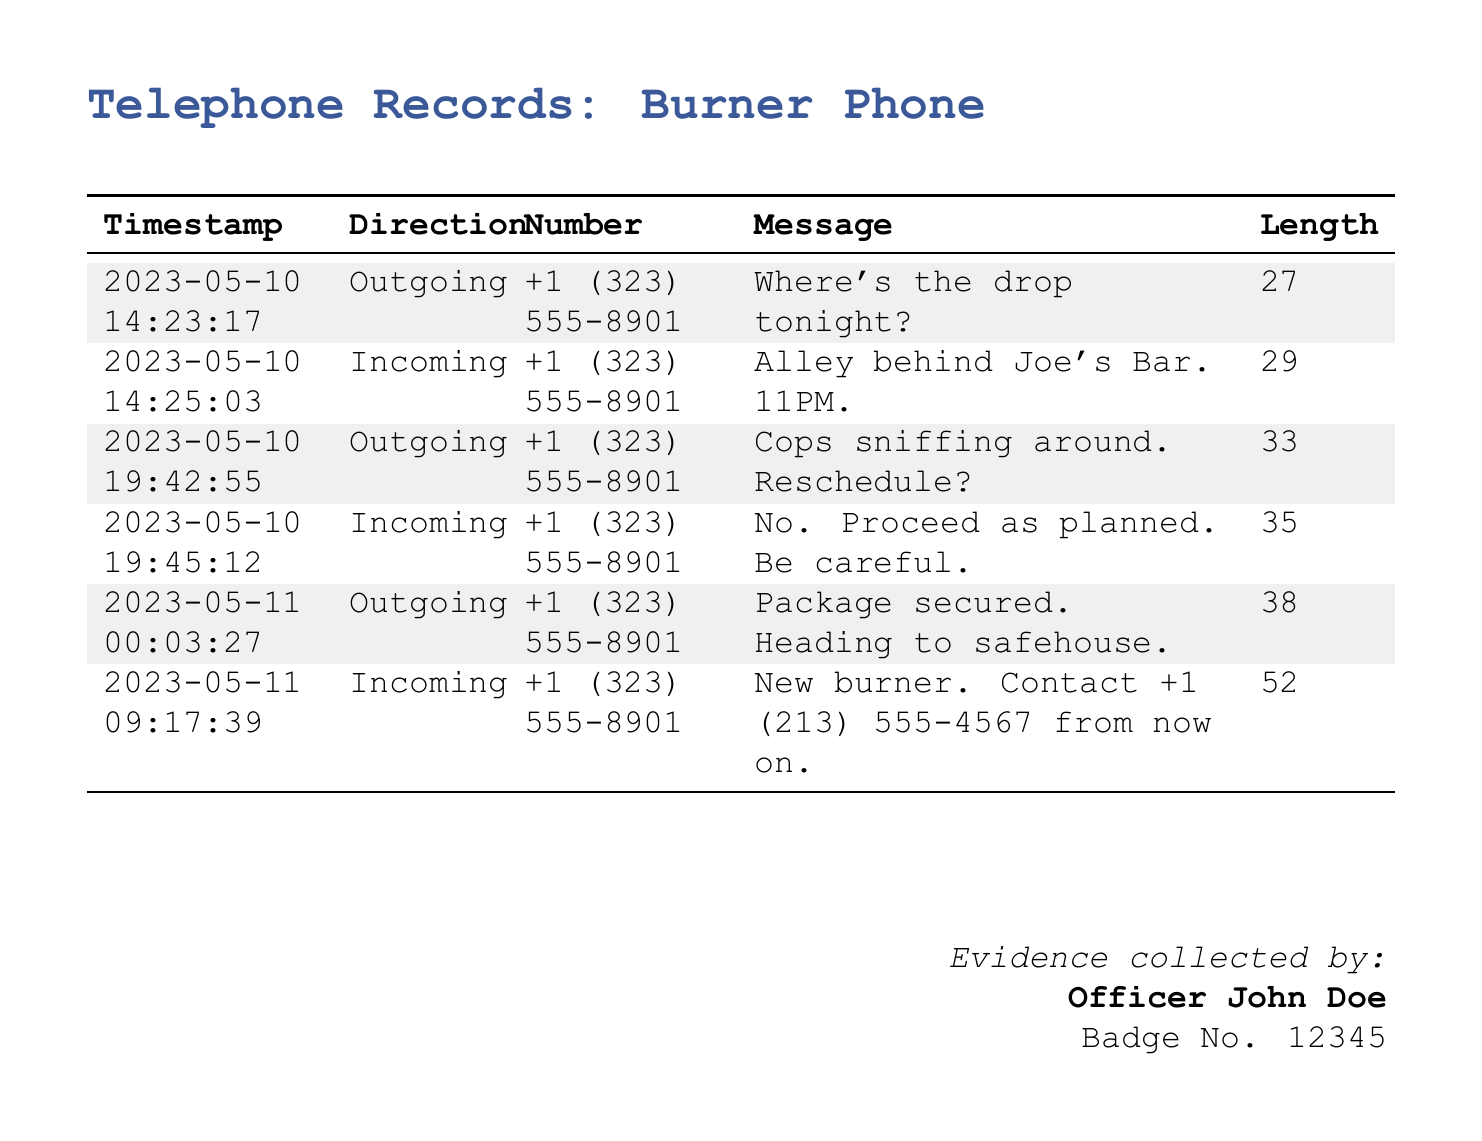What is the timestamp of the first outgoing message? The first outgoing message was sent on May 10, 2023, at 14:23:17.
Answer: 2023-05-10 14:23:17 What message was received in response to the inquiry about the drop location? The incoming message replied with the location for the drop tonight, stating it was an alley behind Joe's Bar.
Answer: Alley behind Joe's Bar. 11PM What is the length of the message that confirms the package's security? The message indicating that the package was secured has a length of 38 characters.
Answer: 38 How many incoming messages are recorded in total? There are three incoming messages detailed in the document.
Answer: 3 What was suggested in the outgoing message on May 10 at 19:42:55? The outgoing message suggested rescheduling due to police presence.
Answer: Reschedule? What is the new contact number provided in the incoming message on May 11? The new contact number mentioned in the message is +1 (213) 555-4567.
Answer: +1 (213) 555-4567 Which two dates are mentioned in the records? The dates mentioned are May 10 and May 11, 2023.
Answer: May 10 and May 11 What does the original sender say about the situation with the cops? The sender communicated concerns about police activity and suggested a reschedule.
Answer: Cops sniffing around Who collected this evidence? The evidence was collected by Officer John Doe.
Answer: Officer John Doe 